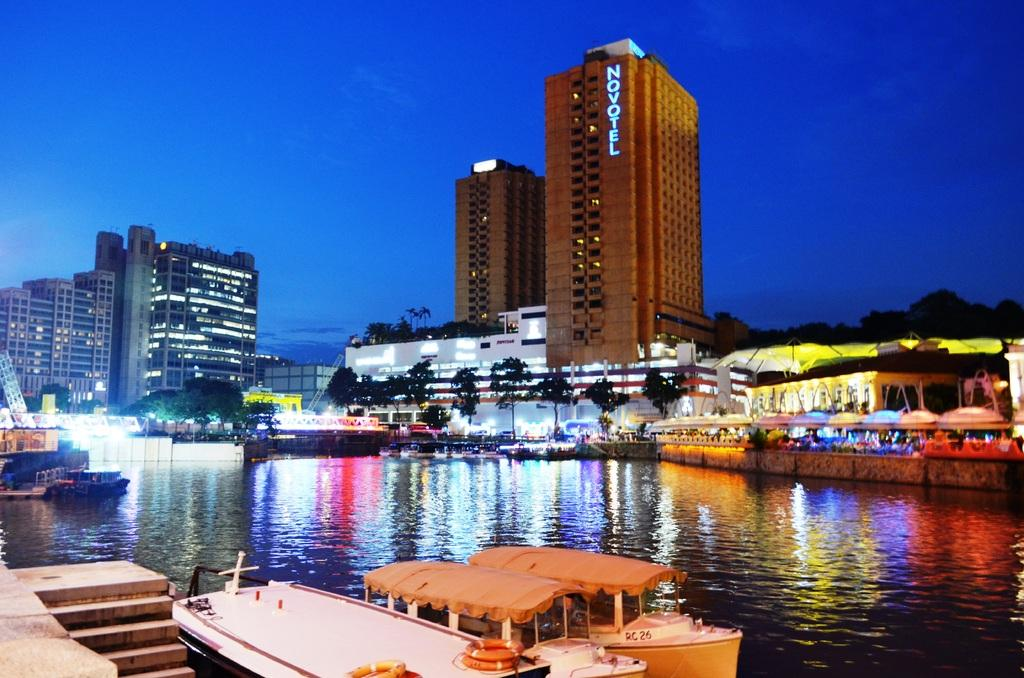What type of structures can be seen in the image? There are buildings in the image. What other natural elements are present in the image? There are trees in the image. What can be seen in the water in the image? There are boats in the water in the image. Can you describe the lighting in the image? The lighting in the image is not specified, but it is mentioned that there is lighting. What color is the sky in the image? The sky is blue in the image. How many goldfish are swimming in the water in the image? There are no goldfish present in the image; it features boats in the water. What type of payment is required to enter the buildings in the image? There is no mention of payment or entering the buildings in the image. 